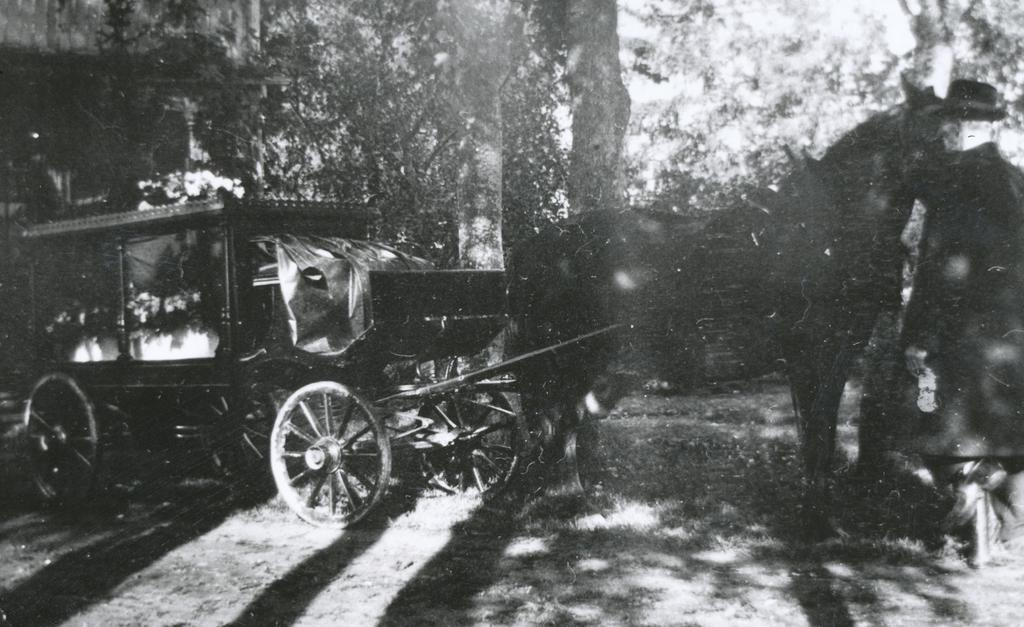What is the color scheme of the image? The image is black and white. Can you describe the age of the image? The image is old. What is the main subject in the middle of the image? There is a horse cart in the middle of the image. How many heads of lettuce can be seen in the image? There are no heads of lettuce present in the image. What is the friction between the horse's legs and the ground in the image? The image is black and white and does not show the horse's legs or the ground, so it is impossible to determine the friction between them. 